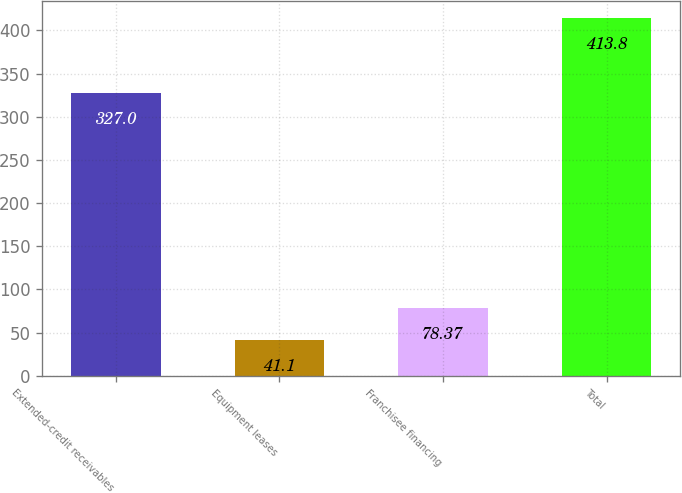<chart> <loc_0><loc_0><loc_500><loc_500><bar_chart><fcel>Extended-credit receivables<fcel>Equipment leases<fcel>Franchisee financing<fcel>Total<nl><fcel>327<fcel>41.1<fcel>78.37<fcel>413.8<nl></chart> 